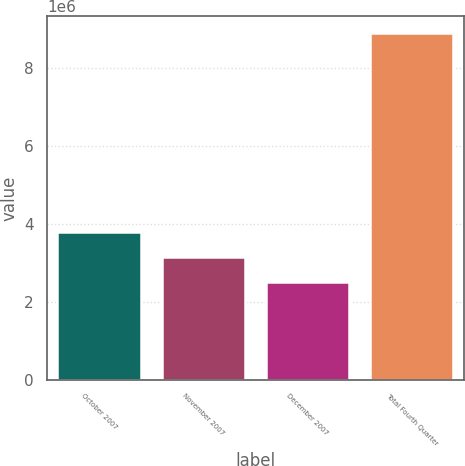<chart> <loc_0><loc_0><loc_500><loc_500><bar_chart><fcel>October 2007<fcel>November 2007<fcel>December 2007<fcel>Total Fourth Quarter<nl><fcel>3.78745e+06<fcel>3.14894e+06<fcel>2.51042e+06<fcel>8.89557e+06<nl></chart> 